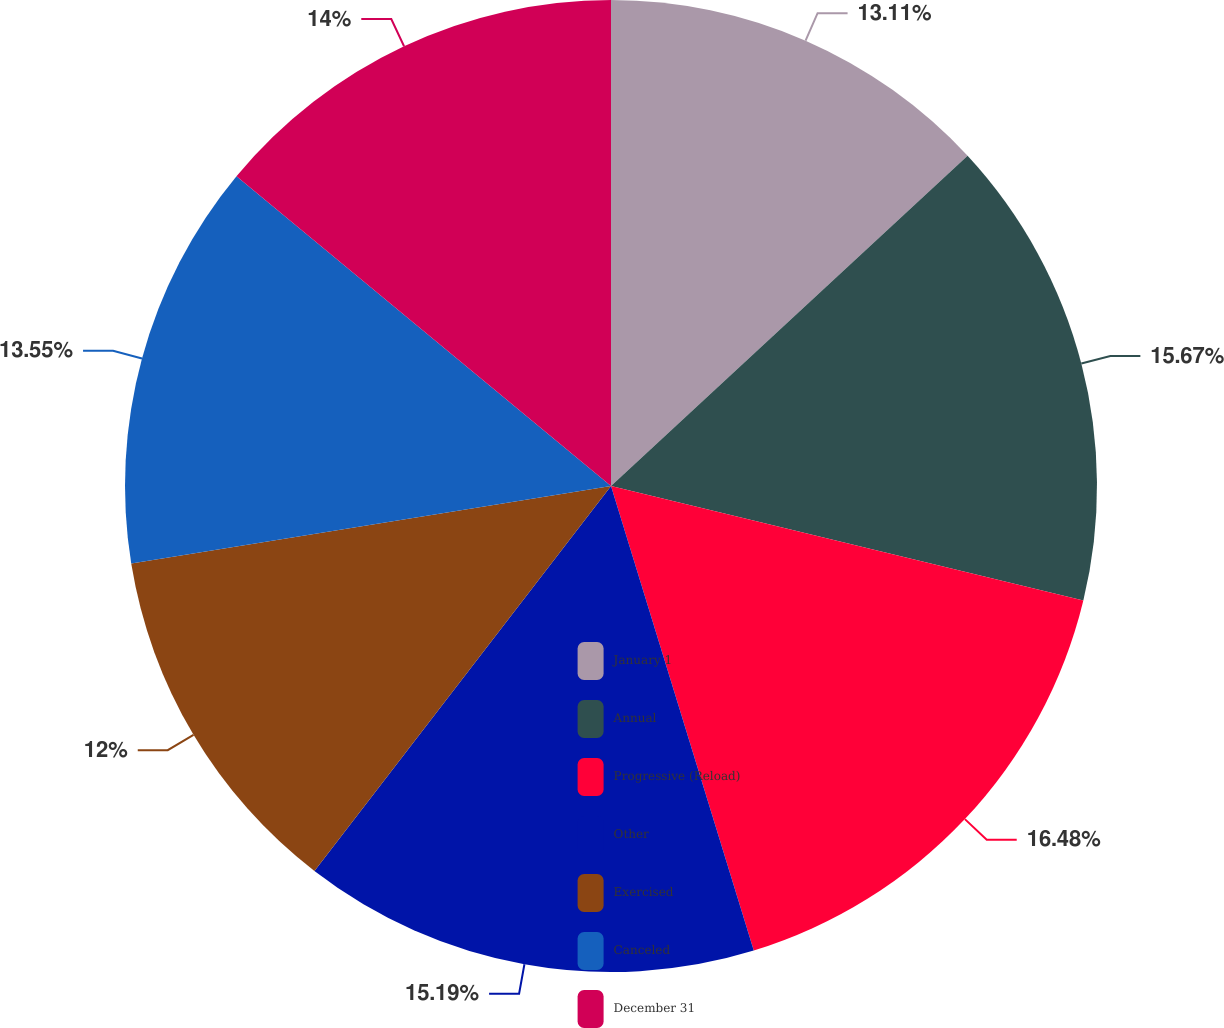Convert chart. <chart><loc_0><loc_0><loc_500><loc_500><pie_chart><fcel>January 1<fcel>Annual<fcel>Progressive (Reload)<fcel>Other<fcel>Exercised<fcel>Canceled<fcel>December 31<nl><fcel>13.11%<fcel>15.67%<fcel>16.47%<fcel>15.19%<fcel>12.0%<fcel>13.55%<fcel>14.0%<nl></chart> 